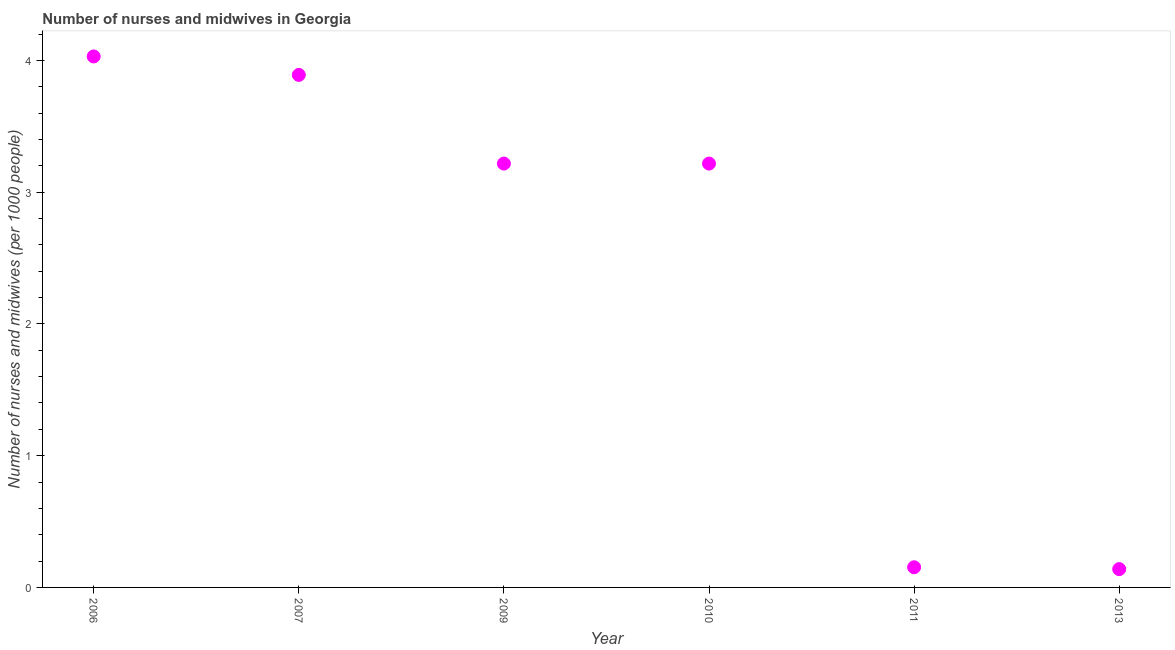What is the number of nurses and midwives in 2006?
Offer a very short reply. 4.03. Across all years, what is the maximum number of nurses and midwives?
Give a very brief answer. 4.03. Across all years, what is the minimum number of nurses and midwives?
Keep it short and to the point. 0.14. In which year was the number of nurses and midwives minimum?
Make the answer very short. 2013. What is the sum of the number of nurses and midwives?
Your answer should be very brief. 14.65. What is the difference between the number of nurses and midwives in 2007 and 2011?
Offer a very short reply. 3.74. What is the average number of nurses and midwives per year?
Give a very brief answer. 2.44. What is the median number of nurses and midwives?
Ensure brevity in your answer.  3.22. What is the ratio of the number of nurses and midwives in 2006 to that in 2013?
Ensure brevity in your answer.  28.99. What is the difference between the highest and the second highest number of nurses and midwives?
Your answer should be very brief. 0.14. Is the sum of the number of nurses and midwives in 2009 and 2010 greater than the maximum number of nurses and midwives across all years?
Make the answer very short. Yes. What is the difference between the highest and the lowest number of nurses and midwives?
Your answer should be compact. 3.89. In how many years, is the number of nurses and midwives greater than the average number of nurses and midwives taken over all years?
Ensure brevity in your answer.  4. Does the number of nurses and midwives monotonically increase over the years?
Ensure brevity in your answer.  No. How many years are there in the graph?
Ensure brevity in your answer.  6. What is the difference between two consecutive major ticks on the Y-axis?
Give a very brief answer. 1. What is the title of the graph?
Your response must be concise. Number of nurses and midwives in Georgia. What is the label or title of the Y-axis?
Offer a very short reply. Number of nurses and midwives (per 1000 people). What is the Number of nurses and midwives (per 1000 people) in 2006?
Provide a short and direct response. 4.03. What is the Number of nurses and midwives (per 1000 people) in 2007?
Offer a terse response. 3.89. What is the Number of nurses and midwives (per 1000 people) in 2009?
Offer a terse response. 3.22. What is the Number of nurses and midwives (per 1000 people) in 2010?
Provide a succinct answer. 3.22. What is the Number of nurses and midwives (per 1000 people) in 2011?
Offer a very short reply. 0.15. What is the Number of nurses and midwives (per 1000 people) in 2013?
Ensure brevity in your answer.  0.14. What is the difference between the Number of nurses and midwives (per 1000 people) in 2006 and 2007?
Your answer should be very brief. 0.14. What is the difference between the Number of nurses and midwives (per 1000 people) in 2006 and 2009?
Keep it short and to the point. 0.81. What is the difference between the Number of nurses and midwives (per 1000 people) in 2006 and 2010?
Provide a short and direct response. 0.81. What is the difference between the Number of nurses and midwives (per 1000 people) in 2006 and 2011?
Your response must be concise. 3.88. What is the difference between the Number of nurses and midwives (per 1000 people) in 2006 and 2013?
Give a very brief answer. 3.89. What is the difference between the Number of nurses and midwives (per 1000 people) in 2007 and 2009?
Your answer should be compact. 0.67. What is the difference between the Number of nurses and midwives (per 1000 people) in 2007 and 2010?
Keep it short and to the point. 0.67. What is the difference between the Number of nurses and midwives (per 1000 people) in 2007 and 2011?
Your response must be concise. 3.74. What is the difference between the Number of nurses and midwives (per 1000 people) in 2007 and 2013?
Ensure brevity in your answer.  3.75. What is the difference between the Number of nurses and midwives (per 1000 people) in 2009 and 2010?
Make the answer very short. 0. What is the difference between the Number of nurses and midwives (per 1000 people) in 2009 and 2011?
Offer a terse response. 3.06. What is the difference between the Number of nurses and midwives (per 1000 people) in 2009 and 2013?
Make the answer very short. 3.08. What is the difference between the Number of nurses and midwives (per 1000 people) in 2010 and 2011?
Give a very brief answer. 3.06. What is the difference between the Number of nurses and midwives (per 1000 people) in 2010 and 2013?
Your answer should be very brief. 3.08. What is the difference between the Number of nurses and midwives (per 1000 people) in 2011 and 2013?
Offer a terse response. 0.01. What is the ratio of the Number of nurses and midwives (per 1000 people) in 2006 to that in 2007?
Provide a short and direct response. 1.04. What is the ratio of the Number of nurses and midwives (per 1000 people) in 2006 to that in 2009?
Ensure brevity in your answer.  1.25. What is the ratio of the Number of nurses and midwives (per 1000 people) in 2006 to that in 2010?
Offer a very short reply. 1.25. What is the ratio of the Number of nurses and midwives (per 1000 people) in 2006 to that in 2011?
Keep it short and to the point. 26.34. What is the ratio of the Number of nurses and midwives (per 1000 people) in 2006 to that in 2013?
Give a very brief answer. 28.99. What is the ratio of the Number of nurses and midwives (per 1000 people) in 2007 to that in 2009?
Offer a terse response. 1.21. What is the ratio of the Number of nurses and midwives (per 1000 people) in 2007 to that in 2010?
Make the answer very short. 1.21. What is the ratio of the Number of nurses and midwives (per 1000 people) in 2007 to that in 2011?
Your answer should be very brief. 25.43. What is the ratio of the Number of nurses and midwives (per 1000 people) in 2007 to that in 2013?
Your response must be concise. 27.99. What is the ratio of the Number of nurses and midwives (per 1000 people) in 2009 to that in 2011?
Make the answer very short. 21.03. What is the ratio of the Number of nurses and midwives (per 1000 people) in 2009 to that in 2013?
Your response must be concise. 23.14. What is the ratio of the Number of nurses and midwives (per 1000 people) in 2010 to that in 2011?
Make the answer very short. 21.03. What is the ratio of the Number of nurses and midwives (per 1000 people) in 2010 to that in 2013?
Offer a very short reply. 23.14. What is the ratio of the Number of nurses and midwives (per 1000 people) in 2011 to that in 2013?
Your answer should be very brief. 1.1. 